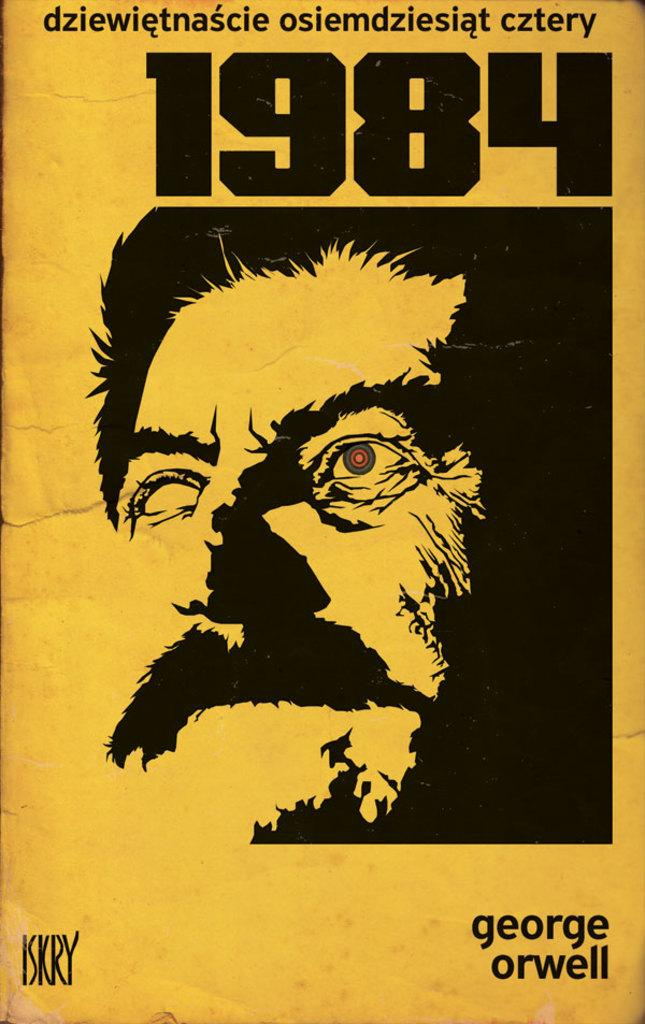<image>
Summarize the visual content of the image. A poster that says 1984 and shows a man with a cyborg eye. 